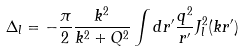Convert formula to latex. <formula><loc_0><loc_0><loc_500><loc_500>\Delta _ { l } = - \frac { \pi } { 2 } \frac { k ^ { 2 } } { k ^ { 2 } + Q ^ { 2 } } \int d r ^ { \prime } \frac { q ^ { 2 } } { r ^ { \prime } } J _ { l } ^ { 2 } ( k r ^ { \prime } )</formula> 